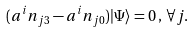<formula> <loc_0><loc_0><loc_500><loc_500>( a ^ { i } n _ { j 3 } - a ^ { i } n _ { j 0 } ) | \Psi \rangle = 0 \, , \, \forall j .</formula> 